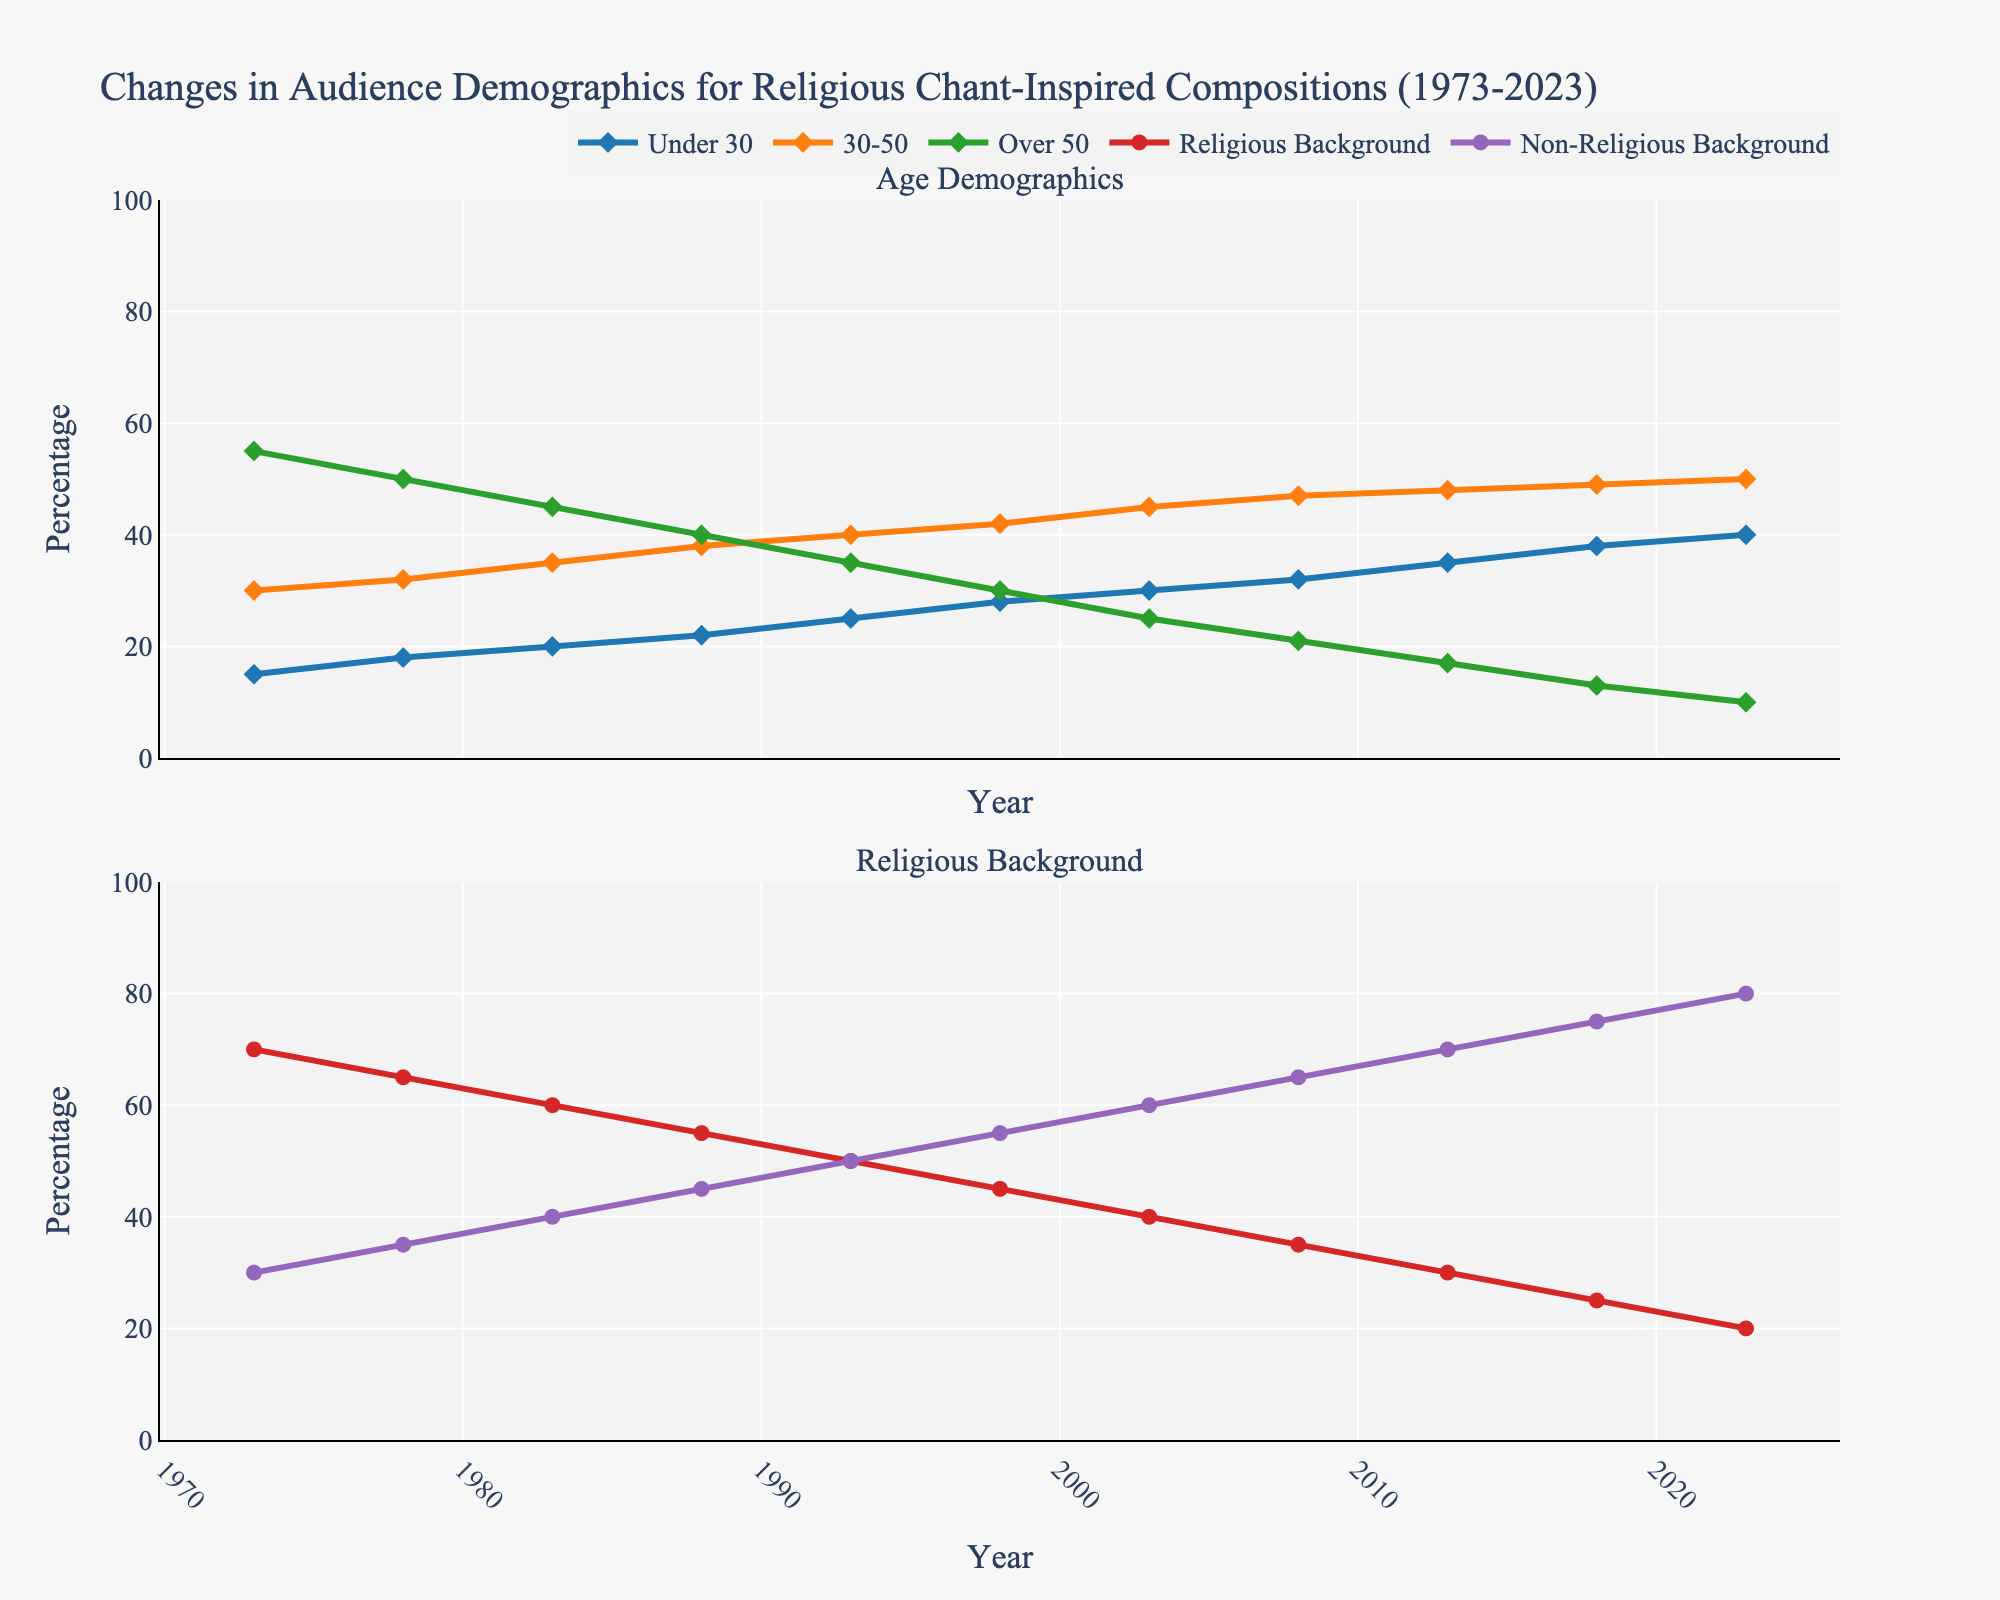What percentage of the audience was under 30 in 2018? The relevant line for the age group "Under 30" shows data points. Check the value corresponding to the year 2018.
Answer: 38 How has the composition of the 30-50 age group changed from 1973 to 2023? Compare the percentage values for the "30-50" category in the years 1973 and 2023 using the chart lines.
Answer: Increased from 30 to 50 Which audience group had the highest percentage in 1973? Look at the starting values for all age and background groups in 1973 and identify the highest value.
Answer: Over 50 Is the percentage of the audience from a non-religious background in 2008 higher or lower than in 1988? Compare the values of the "Non-Religious Background" category for the years 1988 and 2008.
Answer: Higher What is the average percentage of audiences under 30 from 1973 to 2023? Add up the values for "Under 30" from each year and divide by the number of years (11).
Answer: (15 + 18 + 20 + 22 + 25 + 28 + 30 + 32 + 35 + 38 + 40) / 11 = 28.64 What can be inferred about the trend of audiences with a religious background from 1973 to 2023? Observe the trend line for "Religious Background" across the years and see if it is increasing or decreasing.
Answer: Decreasing In which year did the percentage of the "30-50" age group surpass that of the "Over 50" group? Identify the year when the value for the "30-50" line first exceeds the value for the "Over 50" line.
Answer: 1993 How much has the percentage of the audience over 50 decreased from 1983 to 2023? Subtract the value for "Over 50" in 2023 from its value in 1983.
Answer: 45 - 10 = 35 By how much did the percentage of audiences from a non-religious background increase from 1973 to 2023? Subtract the value in 1973 for "Non-Religious Background" from its value in 2023.
Answer: 80 - 30 = 50 Which group saw an increase in percentage every decade from 1973 to 2023? Examine each group and check which one consistently increases across each decade.
Answer: Non-Religious Background 